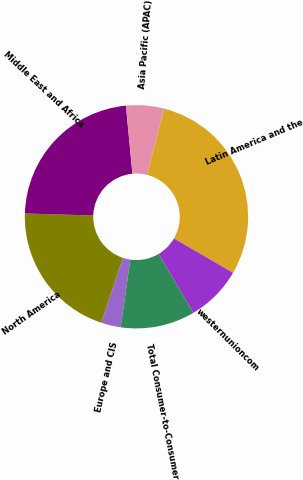Convert chart. <chart><loc_0><loc_0><loc_500><loc_500><pie_chart><fcel>Europe and CIS<fcel>North America<fcel>Middle East and Africa<fcel>Asia Pacific (APAC)<fcel>Latin America and the<fcel>westernunioncom<fcel>Total Consumer-to-Consumer<nl><fcel>2.84%<fcel>20.37%<fcel>23.02%<fcel>5.48%<fcel>29.38%<fcel>8.13%<fcel>10.77%<nl></chart> 